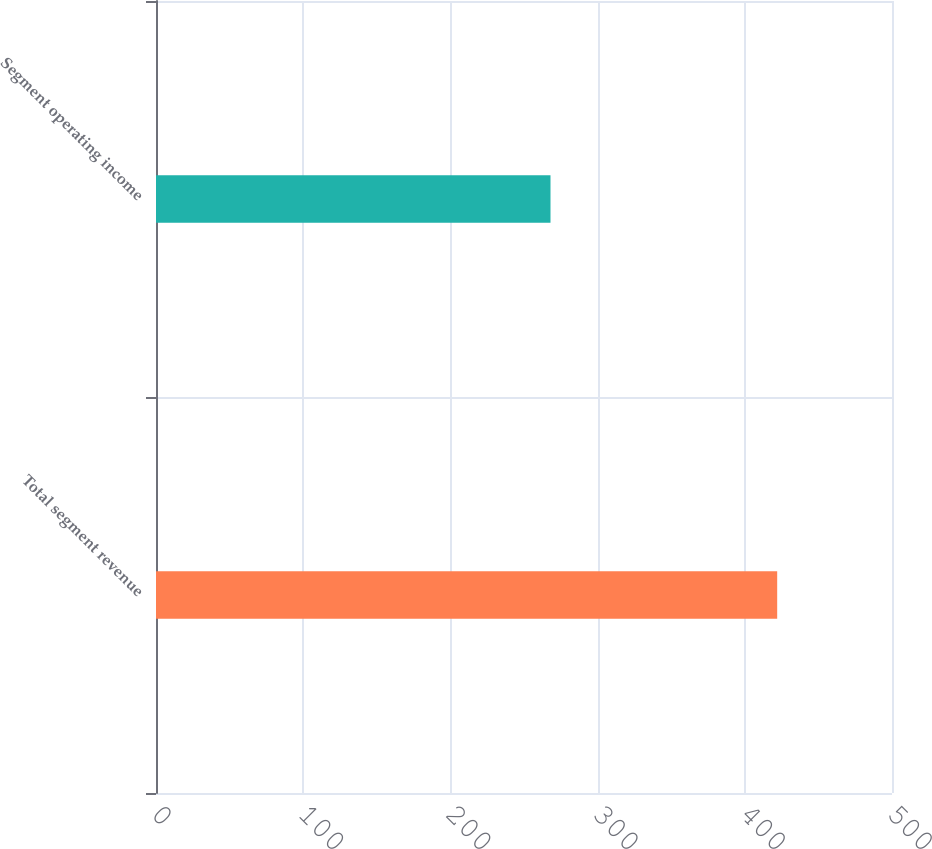<chart> <loc_0><loc_0><loc_500><loc_500><bar_chart><fcel>Total segment revenue<fcel>Segment operating income<nl><fcel>422<fcel>268<nl></chart> 